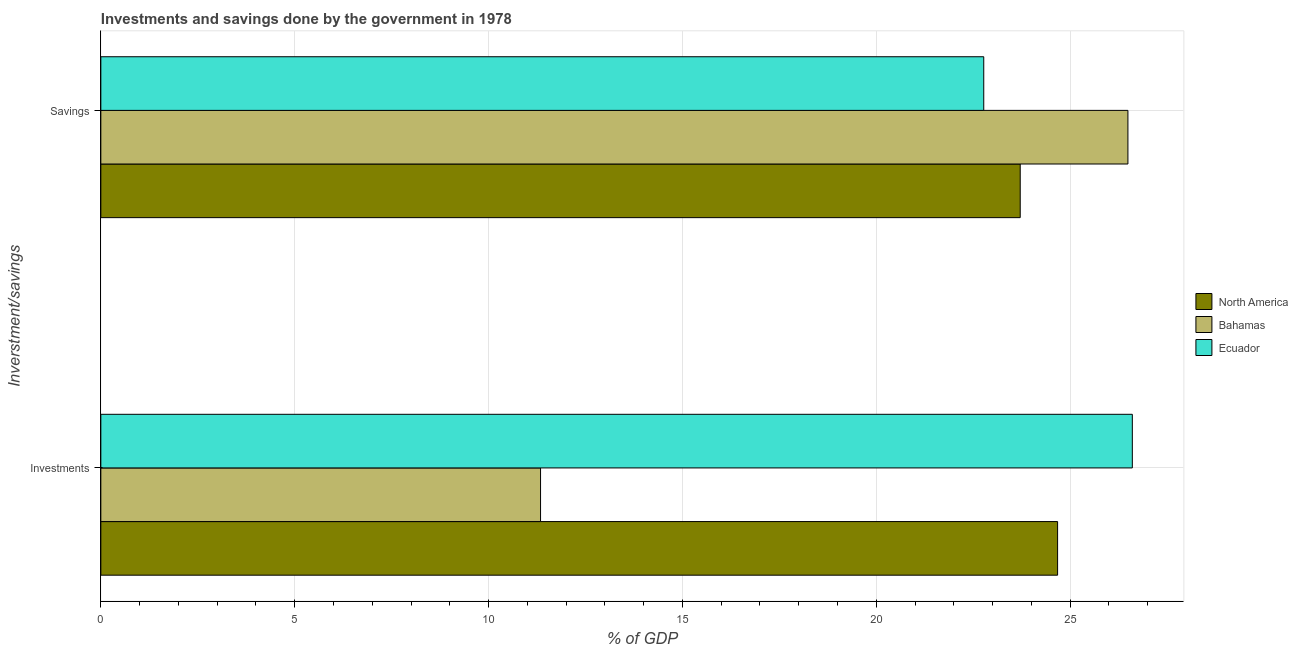How many different coloured bars are there?
Provide a succinct answer. 3. How many groups of bars are there?
Make the answer very short. 2. How many bars are there on the 1st tick from the top?
Offer a very short reply. 3. How many bars are there on the 2nd tick from the bottom?
Ensure brevity in your answer.  3. What is the label of the 2nd group of bars from the top?
Make the answer very short. Investments. What is the investments of government in Bahamas?
Offer a very short reply. 11.34. Across all countries, what is the maximum investments of government?
Keep it short and to the point. 26.6. Across all countries, what is the minimum savings of government?
Offer a very short reply. 22.77. In which country was the savings of government maximum?
Offer a terse response. Bahamas. In which country was the savings of government minimum?
Provide a short and direct response. Ecuador. What is the total investments of government in the graph?
Your response must be concise. 62.62. What is the difference between the savings of government in North America and that in Ecuador?
Your answer should be compact. 0.94. What is the difference between the savings of government in North America and the investments of government in Ecuador?
Give a very brief answer. -2.89. What is the average investments of government per country?
Keep it short and to the point. 20.87. What is the difference between the investments of government and savings of government in North America?
Provide a short and direct response. 0.96. What is the ratio of the savings of government in Ecuador to that in North America?
Provide a succinct answer. 0.96. Is the investments of government in Bahamas less than that in Ecuador?
Provide a succinct answer. Yes. What does the 1st bar from the top in Investments represents?
Give a very brief answer. Ecuador. Are the values on the major ticks of X-axis written in scientific E-notation?
Provide a short and direct response. No. Does the graph contain grids?
Provide a succinct answer. Yes. How many legend labels are there?
Your answer should be compact. 3. How are the legend labels stacked?
Your response must be concise. Vertical. What is the title of the graph?
Your answer should be compact. Investments and savings done by the government in 1978. Does "Bosnia and Herzegovina" appear as one of the legend labels in the graph?
Offer a very short reply. No. What is the label or title of the X-axis?
Offer a very short reply. % of GDP. What is the label or title of the Y-axis?
Give a very brief answer. Inverstment/savings. What is the % of GDP in North America in Investments?
Keep it short and to the point. 24.68. What is the % of GDP in Bahamas in Investments?
Your answer should be compact. 11.34. What is the % of GDP of Ecuador in Investments?
Offer a very short reply. 26.6. What is the % of GDP in North America in Savings?
Your response must be concise. 23.71. What is the % of GDP in Bahamas in Savings?
Make the answer very short. 26.49. What is the % of GDP in Ecuador in Savings?
Your response must be concise. 22.77. Across all Inverstment/savings, what is the maximum % of GDP in North America?
Provide a short and direct response. 24.68. Across all Inverstment/savings, what is the maximum % of GDP of Bahamas?
Your response must be concise. 26.49. Across all Inverstment/savings, what is the maximum % of GDP in Ecuador?
Provide a short and direct response. 26.6. Across all Inverstment/savings, what is the minimum % of GDP in North America?
Your answer should be compact. 23.71. Across all Inverstment/savings, what is the minimum % of GDP of Bahamas?
Your response must be concise. 11.34. Across all Inverstment/savings, what is the minimum % of GDP in Ecuador?
Your answer should be compact. 22.77. What is the total % of GDP in North America in the graph?
Ensure brevity in your answer.  48.39. What is the total % of GDP in Bahamas in the graph?
Make the answer very short. 37.83. What is the total % of GDP of Ecuador in the graph?
Make the answer very short. 49.37. What is the difference between the % of GDP in North America in Investments and that in Savings?
Make the answer very short. 0.96. What is the difference between the % of GDP in Bahamas in Investments and that in Savings?
Offer a terse response. -15.15. What is the difference between the % of GDP in Ecuador in Investments and that in Savings?
Make the answer very short. 3.83. What is the difference between the % of GDP in North America in Investments and the % of GDP in Bahamas in Savings?
Keep it short and to the point. -1.81. What is the difference between the % of GDP of North America in Investments and the % of GDP of Ecuador in Savings?
Your response must be concise. 1.9. What is the difference between the % of GDP of Bahamas in Investments and the % of GDP of Ecuador in Savings?
Your answer should be compact. -11.43. What is the average % of GDP in North America per Inverstment/savings?
Your answer should be compact. 24.19. What is the average % of GDP in Bahamas per Inverstment/savings?
Give a very brief answer. 18.92. What is the average % of GDP of Ecuador per Inverstment/savings?
Provide a succinct answer. 24.69. What is the difference between the % of GDP in North America and % of GDP in Bahamas in Investments?
Provide a short and direct response. 13.34. What is the difference between the % of GDP in North America and % of GDP in Ecuador in Investments?
Make the answer very short. -1.93. What is the difference between the % of GDP of Bahamas and % of GDP of Ecuador in Investments?
Provide a succinct answer. -15.26. What is the difference between the % of GDP in North America and % of GDP in Bahamas in Savings?
Your answer should be very brief. -2.78. What is the difference between the % of GDP in North America and % of GDP in Ecuador in Savings?
Give a very brief answer. 0.94. What is the difference between the % of GDP in Bahamas and % of GDP in Ecuador in Savings?
Keep it short and to the point. 3.72. What is the ratio of the % of GDP in North America in Investments to that in Savings?
Offer a very short reply. 1.04. What is the ratio of the % of GDP in Bahamas in Investments to that in Savings?
Ensure brevity in your answer.  0.43. What is the ratio of the % of GDP of Ecuador in Investments to that in Savings?
Your answer should be very brief. 1.17. What is the difference between the highest and the second highest % of GDP of North America?
Provide a succinct answer. 0.96. What is the difference between the highest and the second highest % of GDP in Bahamas?
Provide a short and direct response. 15.15. What is the difference between the highest and the second highest % of GDP in Ecuador?
Give a very brief answer. 3.83. What is the difference between the highest and the lowest % of GDP of North America?
Your answer should be very brief. 0.96. What is the difference between the highest and the lowest % of GDP of Bahamas?
Keep it short and to the point. 15.15. What is the difference between the highest and the lowest % of GDP in Ecuador?
Offer a terse response. 3.83. 